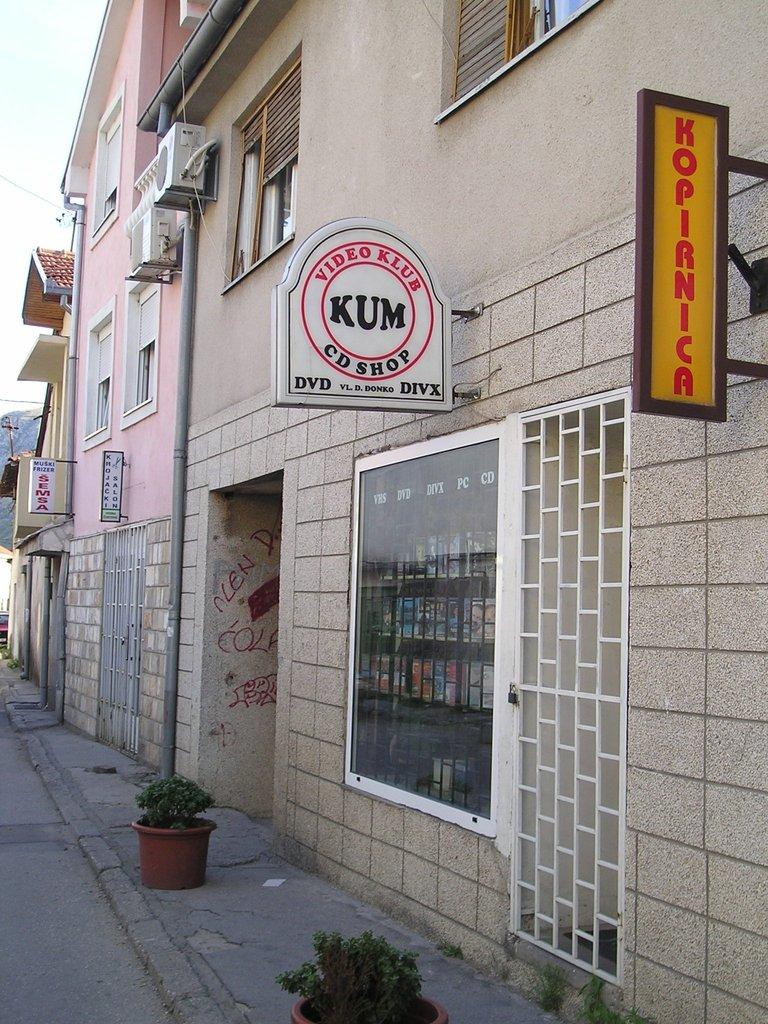What type of structures can be seen in the image? There are buildings in the image. What is attached to the buildings? Boards are attached to the buildings. What objects are present at the bottom of the image? Pots are present at the bottom of the image. What is the angle of the slope in the image? There is no slope present in the image. What is the desire of the moon in the image? The moon is not present in the image, so it cannot have any desires. 